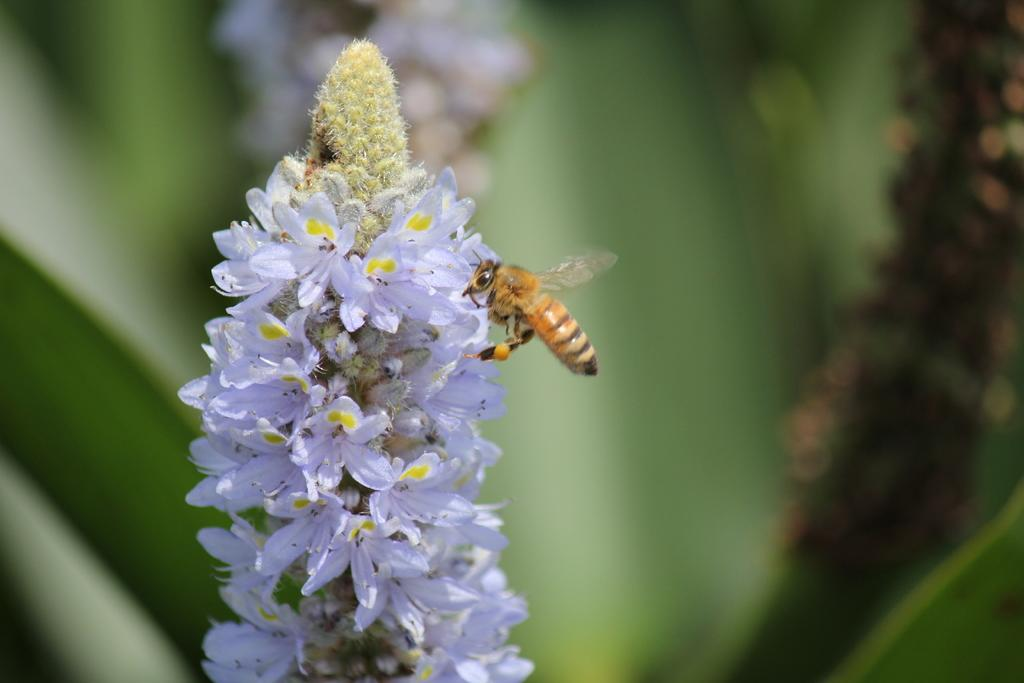What is the main subject of the image? There is an insect in the image. Where is the insect located? The insect is on flowers. Can you describe the background of the image? The background of the image is blurred. What else can be seen in the background of the image? There are objects visible in the background of the image. What type of muscle can be seen flexing in the image? There is no muscle present in the image; it features an insect on flowers. How does the weather affect the insect in the image? The provided facts do not mention any weather conditions, so we cannot determine how the weather might affect the insect in the image. 